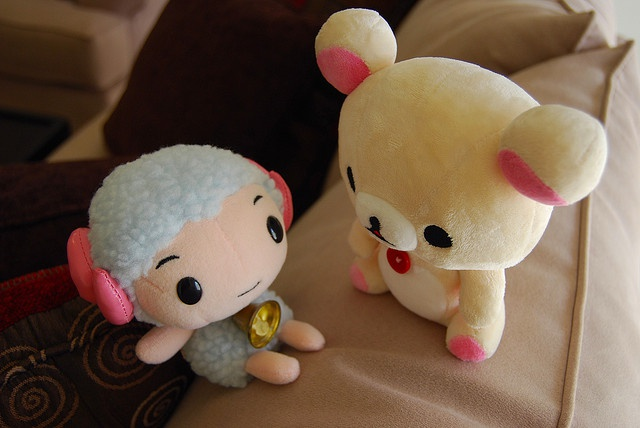Describe the objects in this image and their specific colors. I can see couch in maroon, brown, gray, darkgray, and tan tones and teddy bear in maroon, gray, tan, and olive tones in this image. 